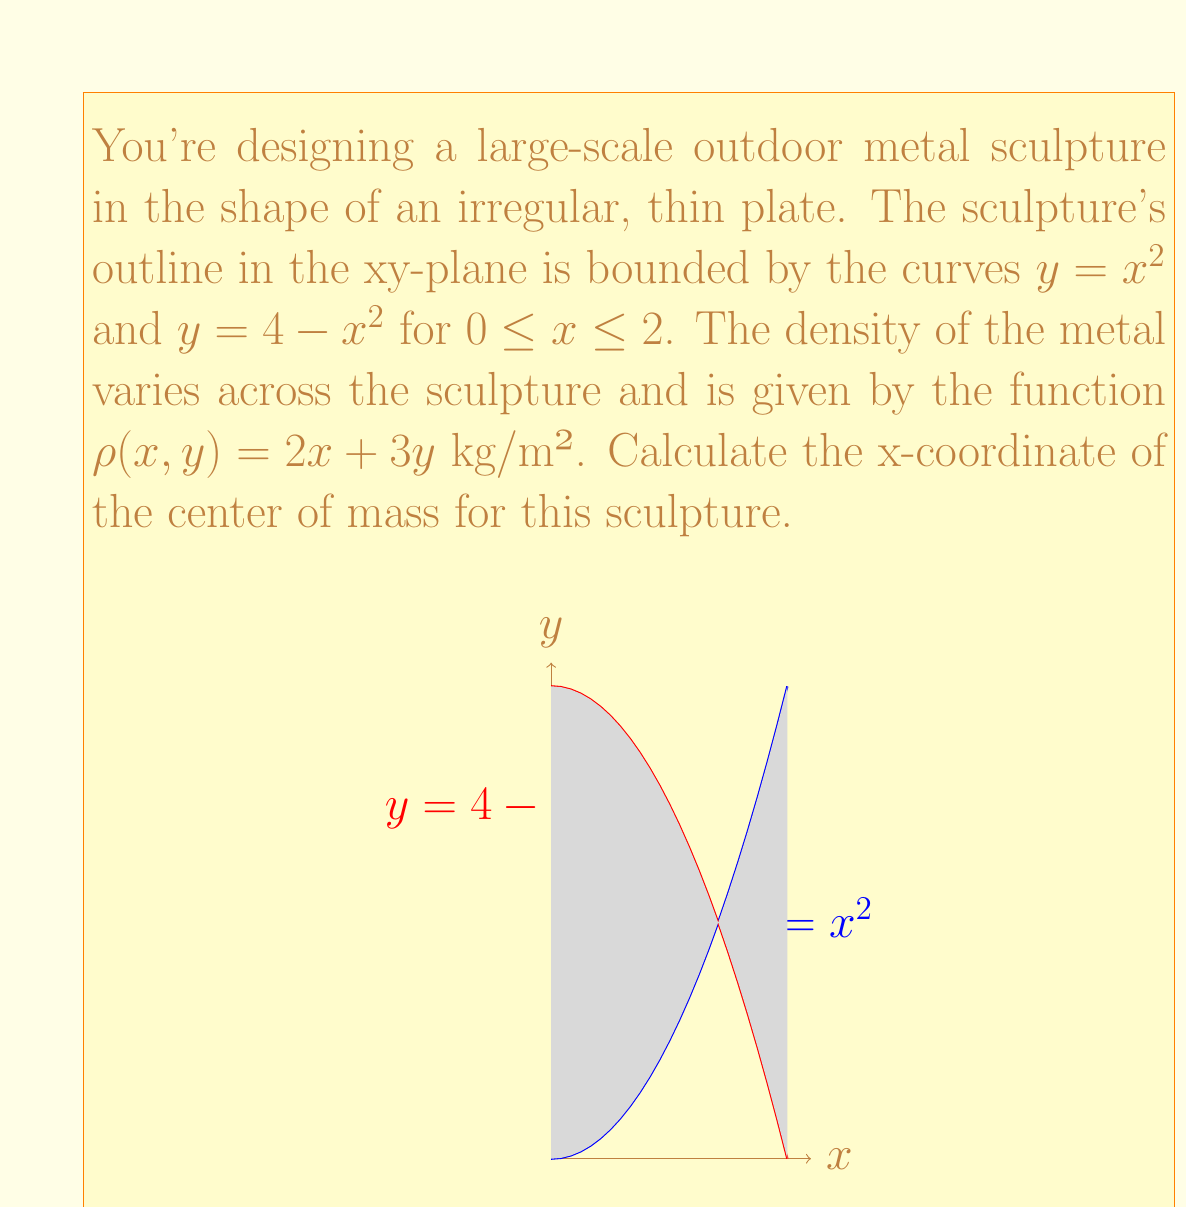Show me your answer to this math problem. To find the x-coordinate of the center of mass, we need to use the formula:

$$x_{cm} = \frac{\iint_R x\rho(x,y) \, dA}{\iint_R \rho(x,y) \, dA}$$

Where $R$ is the region of the sculpture, and $\rho(x,y)$ is the density function.

Step 1: Set up the double integrals for the numerator and denominator.
Numerator: $\int_0^2 \int_{x^2}^{4-x^2} x(2x+3y) \, dy \, dx$
Denominator: $\int_0^2 \int_{x^2}^{4-x^2} (2x+3y) \, dy \, dx$

Step 2: Evaluate the inner integral of the numerator.
$\int_0^2 \int_{x^2}^{4-x^2} x(2x+3y) \, dy \, dx$
$= \int_0^2 x[2xy + \frac{3}{2}y^2]_{x^2}^{4-x^2} \, dx$
$= \int_0^2 x[2x(4-x^2) + \frac{3}{2}(4-x^2)^2 - 2x^3 - \frac{3}{2}x^4] \, dx$
$= \int_0^2 (8x^2 - 2x^4 + 24x - 12x^3 - \frac{3}{2}x^5) \, dx$

Step 3: Evaluate the inner integral of the denominator.
$\int_0^2 \int_{x^2}^{4-x^2} (2x+3y) \, dy \, dx$
$= \int_0^2 [2xy + \frac{3}{2}y^2]_{x^2}^{4-x^2} \, dx$
$= \int_0^2 [2x(4-x^2) + \frac{3}{2}(4-x^2)^2 - 2x^3 - \frac{3}{2}x^4] \, dx$
$= \int_0^2 (8x - 2x^3 + 24 - 12x^2 - \frac{3}{2}x^4) \, dx$

Step 4: Evaluate the outer integrals.
Numerator: $[\frac{8}{3}x^3 - \frac{2}{5}x^5 + 12x^2 - 3x^4 - \frac{1}{4}x^6]_0^2 = \frac{256}{15}$
Denominator: $[4x^2 - \frac{1}{2}x^4 + 24x - 4x^3 - \frac{3}{10}x^5]_0^2 = \frac{64}{3}$

Step 5: Calculate the x-coordinate of the center of mass.
$$x_{cm} = \frac{256/15}{64/3} = \frac{4}{5} = 0.8$$
Answer: $x_{cm} = 0.8$ m 